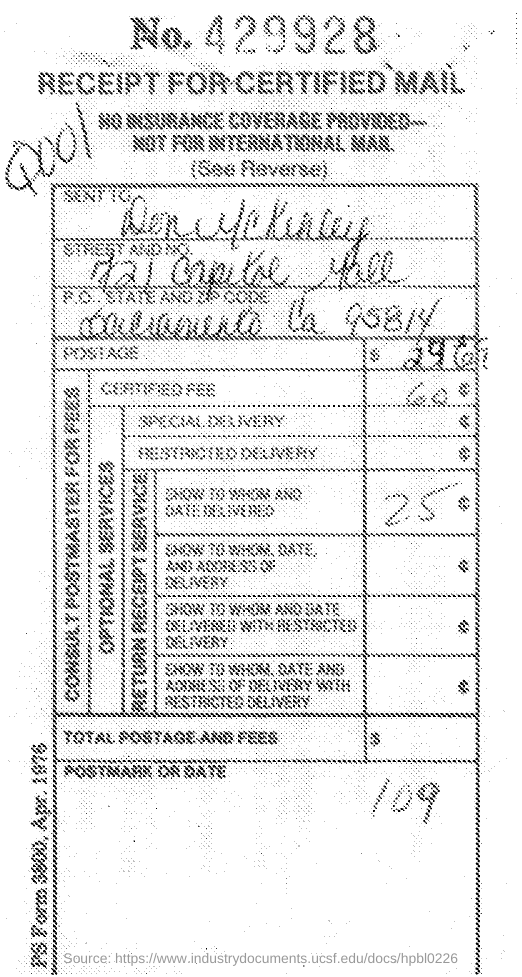Draw attention to some important aspects in this diagram. This is a receipt for certified mail. The cost of certification is USD 60. The receipt number is 429928. 